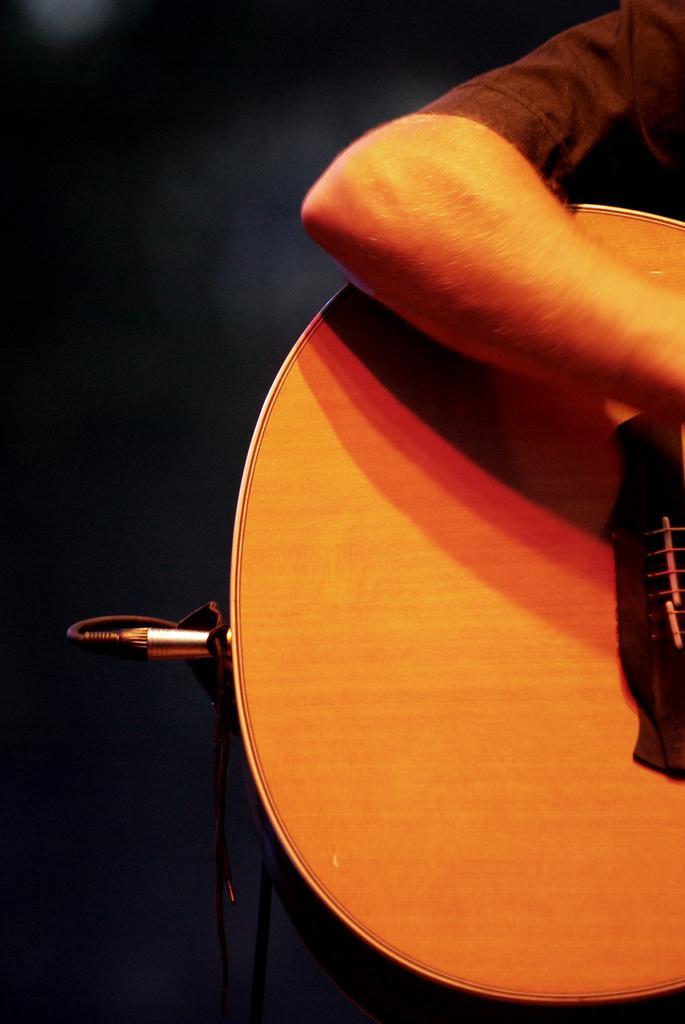How would you summarize this image in a sentence or two? A person holding a guitar which it has some wires inserted in it. 